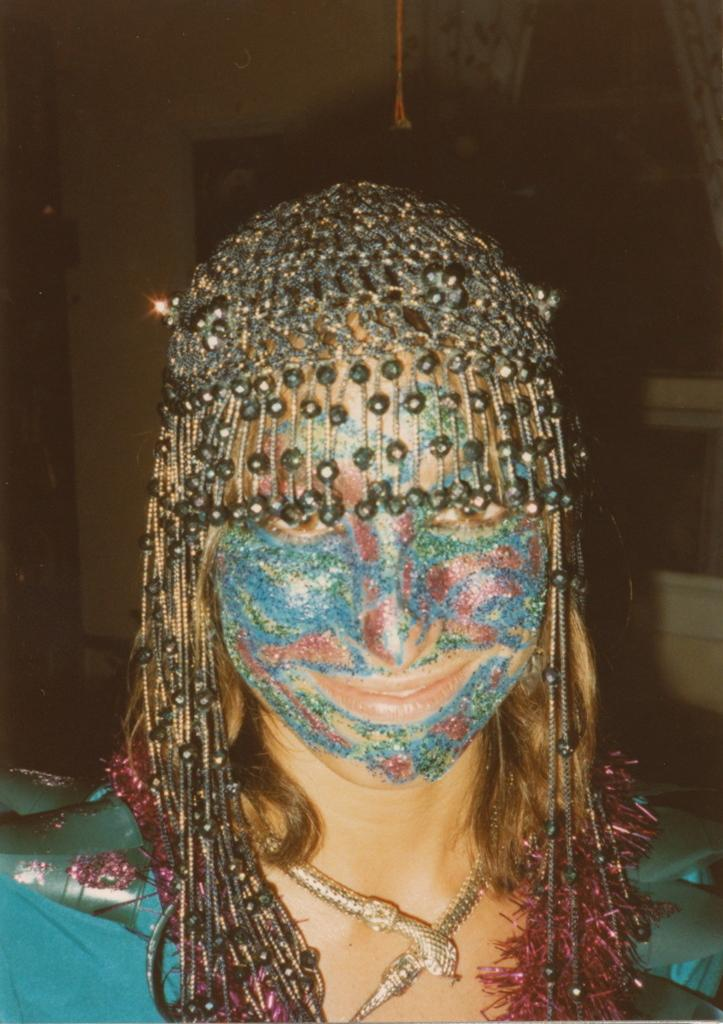Who is the main subject in the image? There is a woman in the image. What is the woman wearing in the image? The woman is wearing ornaments and a necklace in the image. Can you describe the woman's face in the image? The woman has face paint in the image. Where is the library located in the image? There is no library present in the image. What type of toy can be seen in the woman's hand in the image? There is no toy visible in the woman's hand in the image. 